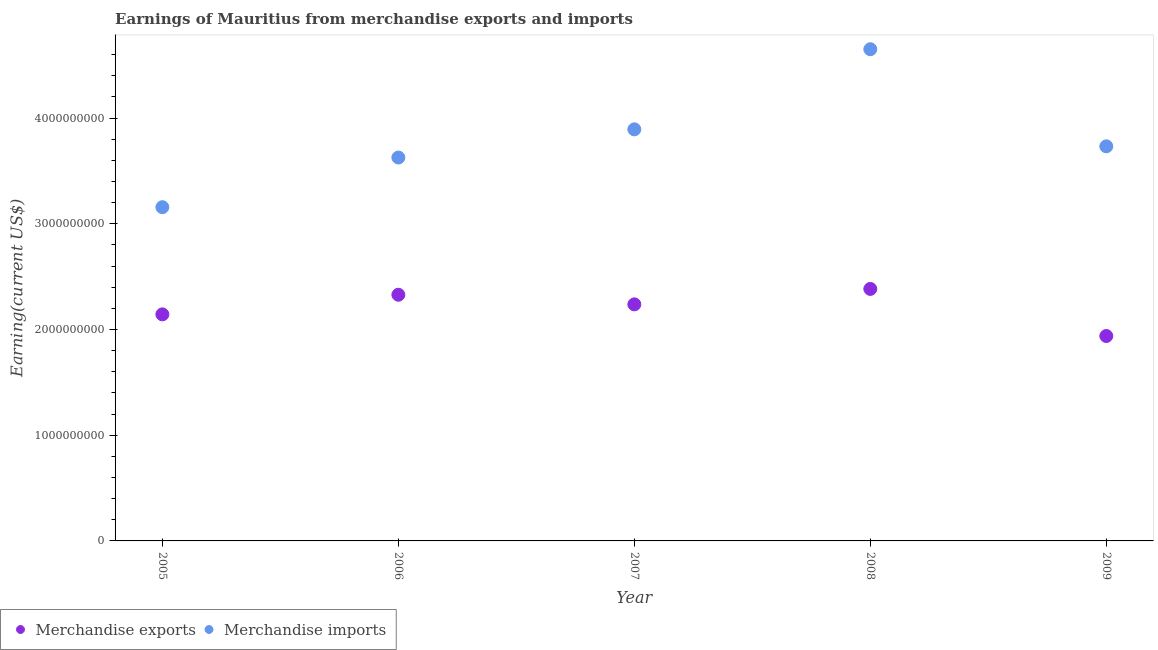What is the earnings from merchandise exports in 2008?
Your answer should be very brief. 2.38e+09. Across all years, what is the maximum earnings from merchandise imports?
Provide a short and direct response. 4.65e+09. Across all years, what is the minimum earnings from merchandise imports?
Ensure brevity in your answer.  3.16e+09. What is the total earnings from merchandise imports in the graph?
Make the answer very short. 1.91e+1. What is the difference between the earnings from merchandise imports in 2005 and that in 2007?
Give a very brief answer. -7.37e+08. What is the difference between the earnings from merchandise imports in 2006 and the earnings from merchandise exports in 2005?
Keep it short and to the point. 1.48e+09. What is the average earnings from merchandise imports per year?
Provide a short and direct response. 3.81e+09. In the year 2009, what is the difference between the earnings from merchandise exports and earnings from merchandise imports?
Keep it short and to the point. -1.79e+09. What is the ratio of the earnings from merchandise exports in 2006 to that in 2009?
Ensure brevity in your answer.  1.2. Is the earnings from merchandise imports in 2005 less than that in 2008?
Provide a short and direct response. Yes. What is the difference between the highest and the second highest earnings from merchandise imports?
Provide a short and direct response. 7.58e+08. What is the difference between the highest and the lowest earnings from merchandise exports?
Ensure brevity in your answer.  4.45e+08. In how many years, is the earnings from merchandise exports greater than the average earnings from merchandise exports taken over all years?
Give a very brief answer. 3. Is the sum of the earnings from merchandise exports in 2005 and 2007 greater than the maximum earnings from merchandise imports across all years?
Your response must be concise. No. Is the earnings from merchandise exports strictly greater than the earnings from merchandise imports over the years?
Your answer should be compact. No. Is the earnings from merchandise exports strictly less than the earnings from merchandise imports over the years?
Ensure brevity in your answer.  Yes. How many years are there in the graph?
Keep it short and to the point. 5. What is the difference between two consecutive major ticks on the Y-axis?
Make the answer very short. 1.00e+09. Are the values on the major ticks of Y-axis written in scientific E-notation?
Provide a succinct answer. No. Does the graph contain grids?
Your response must be concise. No. What is the title of the graph?
Keep it short and to the point. Earnings of Mauritius from merchandise exports and imports. What is the label or title of the X-axis?
Your answer should be very brief. Year. What is the label or title of the Y-axis?
Provide a succinct answer. Earning(current US$). What is the Earning(current US$) in Merchandise exports in 2005?
Make the answer very short. 2.14e+09. What is the Earning(current US$) of Merchandise imports in 2005?
Offer a very short reply. 3.16e+09. What is the Earning(current US$) in Merchandise exports in 2006?
Provide a succinct answer. 2.33e+09. What is the Earning(current US$) of Merchandise imports in 2006?
Ensure brevity in your answer.  3.63e+09. What is the Earning(current US$) in Merchandise exports in 2007?
Provide a short and direct response. 2.24e+09. What is the Earning(current US$) of Merchandise imports in 2007?
Ensure brevity in your answer.  3.89e+09. What is the Earning(current US$) in Merchandise exports in 2008?
Make the answer very short. 2.38e+09. What is the Earning(current US$) of Merchandise imports in 2008?
Give a very brief answer. 4.65e+09. What is the Earning(current US$) of Merchandise exports in 2009?
Ensure brevity in your answer.  1.94e+09. What is the Earning(current US$) of Merchandise imports in 2009?
Ensure brevity in your answer.  3.73e+09. Across all years, what is the maximum Earning(current US$) in Merchandise exports?
Ensure brevity in your answer.  2.38e+09. Across all years, what is the maximum Earning(current US$) of Merchandise imports?
Your answer should be very brief. 4.65e+09. Across all years, what is the minimum Earning(current US$) of Merchandise exports?
Offer a very short reply. 1.94e+09. Across all years, what is the minimum Earning(current US$) in Merchandise imports?
Keep it short and to the point. 3.16e+09. What is the total Earning(current US$) of Merchandise exports in the graph?
Your answer should be compact. 1.10e+1. What is the total Earning(current US$) in Merchandise imports in the graph?
Your answer should be compact. 1.91e+1. What is the difference between the Earning(current US$) of Merchandise exports in 2005 and that in 2006?
Offer a terse response. -1.86e+08. What is the difference between the Earning(current US$) of Merchandise imports in 2005 and that in 2006?
Your response must be concise. -4.70e+08. What is the difference between the Earning(current US$) in Merchandise exports in 2005 and that in 2007?
Keep it short and to the point. -9.46e+07. What is the difference between the Earning(current US$) of Merchandise imports in 2005 and that in 2007?
Your answer should be compact. -7.37e+08. What is the difference between the Earning(current US$) of Merchandise exports in 2005 and that in 2008?
Your answer should be very brief. -2.41e+08. What is the difference between the Earning(current US$) in Merchandise imports in 2005 and that in 2008?
Offer a terse response. -1.49e+09. What is the difference between the Earning(current US$) of Merchandise exports in 2005 and that in 2009?
Give a very brief answer. 2.05e+08. What is the difference between the Earning(current US$) in Merchandise imports in 2005 and that in 2009?
Make the answer very short. -5.76e+08. What is the difference between the Earning(current US$) of Merchandise exports in 2006 and that in 2007?
Ensure brevity in your answer.  9.09e+07. What is the difference between the Earning(current US$) of Merchandise imports in 2006 and that in 2007?
Your response must be concise. -2.67e+08. What is the difference between the Earning(current US$) in Merchandise exports in 2006 and that in 2008?
Your answer should be compact. -5.51e+07. What is the difference between the Earning(current US$) in Merchandise imports in 2006 and that in 2008?
Give a very brief answer. -1.02e+09. What is the difference between the Earning(current US$) of Merchandise exports in 2006 and that in 2009?
Make the answer very short. 3.90e+08. What is the difference between the Earning(current US$) of Merchandise imports in 2006 and that in 2009?
Provide a succinct answer. -1.06e+08. What is the difference between the Earning(current US$) in Merchandise exports in 2007 and that in 2008?
Give a very brief answer. -1.46e+08. What is the difference between the Earning(current US$) of Merchandise imports in 2007 and that in 2008?
Offer a very short reply. -7.58e+08. What is the difference between the Earning(current US$) in Merchandise exports in 2007 and that in 2009?
Offer a terse response. 2.99e+08. What is the difference between the Earning(current US$) of Merchandise imports in 2007 and that in 2009?
Your answer should be very brief. 1.61e+08. What is the difference between the Earning(current US$) in Merchandise exports in 2008 and that in 2009?
Give a very brief answer. 4.45e+08. What is the difference between the Earning(current US$) of Merchandise imports in 2008 and that in 2009?
Give a very brief answer. 9.19e+08. What is the difference between the Earning(current US$) in Merchandise exports in 2005 and the Earning(current US$) in Merchandise imports in 2006?
Keep it short and to the point. -1.48e+09. What is the difference between the Earning(current US$) in Merchandise exports in 2005 and the Earning(current US$) in Merchandise imports in 2007?
Make the answer very short. -1.75e+09. What is the difference between the Earning(current US$) in Merchandise exports in 2005 and the Earning(current US$) in Merchandise imports in 2008?
Provide a succinct answer. -2.51e+09. What is the difference between the Earning(current US$) in Merchandise exports in 2005 and the Earning(current US$) in Merchandise imports in 2009?
Make the answer very short. -1.59e+09. What is the difference between the Earning(current US$) of Merchandise exports in 2006 and the Earning(current US$) of Merchandise imports in 2007?
Give a very brief answer. -1.56e+09. What is the difference between the Earning(current US$) of Merchandise exports in 2006 and the Earning(current US$) of Merchandise imports in 2008?
Keep it short and to the point. -2.32e+09. What is the difference between the Earning(current US$) in Merchandise exports in 2006 and the Earning(current US$) in Merchandise imports in 2009?
Keep it short and to the point. -1.40e+09. What is the difference between the Earning(current US$) of Merchandise exports in 2007 and the Earning(current US$) of Merchandise imports in 2008?
Ensure brevity in your answer.  -2.41e+09. What is the difference between the Earning(current US$) in Merchandise exports in 2007 and the Earning(current US$) in Merchandise imports in 2009?
Offer a very short reply. -1.49e+09. What is the difference between the Earning(current US$) of Merchandise exports in 2008 and the Earning(current US$) of Merchandise imports in 2009?
Your answer should be very brief. -1.35e+09. What is the average Earning(current US$) in Merchandise exports per year?
Make the answer very short. 2.21e+09. What is the average Earning(current US$) in Merchandise imports per year?
Your answer should be very brief. 3.81e+09. In the year 2005, what is the difference between the Earning(current US$) of Merchandise exports and Earning(current US$) of Merchandise imports?
Provide a short and direct response. -1.01e+09. In the year 2006, what is the difference between the Earning(current US$) in Merchandise exports and Earning(current US$) in Merchandise imports?
Your response must be concise. -1.30e+09. In the year 2007, what is the difference between the Earning(current US$) of Merchandise exports and Earning(current US$) of Merchandise imports?
Ensure brevity in your answer.  -1.66e+09. In the year 2008, what is the difference between the Earning(current US$) in Merchandise exports and Earning(current US$) in Merchandise imports?
Provide a succinct answer. -2.27e+09. In the year 2009, what is the difference between the Earning(current US$) of Merchandise exports and Earning(current US$) of Merchandise imports?
Ensure brevity in your answer.  -1.79e+09. What is the ratio of the Earning(current US$) of Merchandise exports in 2005 to that in 2006?
Your answer should be very brief. 0.92. What is the ratio of the Earning(current US$) in Merchandise imports in 2005 to that in 2006?
Ensure brevity in your answer.  0.87. What is the ratio of the Earning(current US$) of Merchandise exports in 2005 to that in 2007?
Offer a terse response. 0.96. What is the ratio of the Earning(current US$) of Merchandise imports in 2005 to that in 2007?
Your answer should be very brief. 0.81. What is the ratio of the Earning(current US$) of Merchandise exports in 2005 to that in 2008?
Ensure brevity in your answer.  0.9. What is the ratio of the Earning(current US$) in Merchandise imports in 2005 to that in 2008?
Keep it short and to the point. 0.68. What is the ratio of the Earning(current US$) of Merchandise exports in 2005 to that in 2009?
Your response must be concise. 1.11. What is the ratio of the Earning(current US$) in Merchandise imports in 2005 to that in 2009?
Give a very brief answer. 0.85. What is the ratio of the Earning(current US$) of Merchandise exports in 2006 to that in 2007?
Provide a short and direct response. 1.04. What is the ratio of the Earning(current US$) of Merchandise imports in 2006 to that in 2007?
Give a very brief answer. 0.93. What is the ratio of the Earning(current US$) of Merchandise exports in 2006 to that in 2008?
Make the answer very short. 0.98. What is the ratio of the Earning(current US$) of Merchandise imports in 2006 to that in 2008?
Ensure brevity in your answer.  0.78. What is the ratio of the Earning(current US$) of Merchandise exports in 2006 to that in 2009?
Your answer should be compact. 1.2. What is the ratio of the Earning(current US$) of Merchandise imports in 2006 to that in 2009?
Make the answer very short. 0.97. What is the ratio of the Earning(current US$) in Merchandise exports in 2007 to that in 2008?
Offer a terse response. 0.94. What is the ratio of the Earning(current US$) in Merchandise imports in 2007 to that in 2008?
Make the answer very short. 0.84. What is the ratio of the Earning(current US$) of Merchandise exports in 2007 to that in 2009?
Keep it short and to the point. 1.15. What is the ratio of the Earning(current US$) of Merchandise imports in 2007 to that in 2009?
Provide a short and direct response. 1.04. What is the ratio of the Earning(current US$) of Merchandise exports in 2008 to that in 2009?
Provide a succinct answer. 1.23. What is the ratio of the Earning(current US$) of Merchandise imports in 2008 to that in 2009?
Give a very brief answer. 1.25. What is the difference between the highest and the second highest Earning(current US$) of Merchandise exports?
Make the answer very short. 5.51e+07. What is the difference between the highest and the second highest Earning(current US$) of Merchandise imports?
Provide a short and direct response. 7.58e+08. What is the difference between the highest and the lowest Earning(current US$) of Merchandise exports?
Your response must be concise. 4.45e+08. What is the difference between the highest and the lowest Earning(current US$) in Merchandise imports?
Your response must be concise. 1.49e+09. 